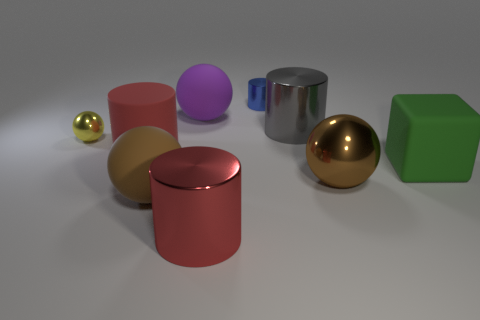How many objects are there in total in this image? There are nine objects in total in the image, each with a distinct shape and color. 